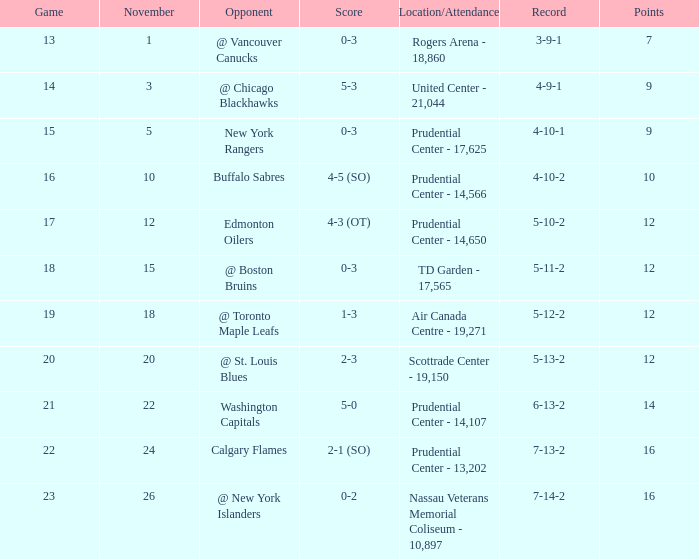What is the record for score 1-3? 5-12-2. I'm looking to parse the entire table for insights. Could you assist me with that? {'header': ['Game', 'November', 'Opponent', 'Score', 'Location/Attendance', 'Record', 'Points'], 'rows': [['13', '1', '@ Vancouver Canucks', '0-3', 'Rogers Arena - 18,860', '3-9-1', '7'], ['14', '3', '@ Chicago Blackhawks', '5-3', 'United Center - 21,044', '4-9-1', '9'], ['15', '5', 'New York Rangers', '0-3', 'Prudential Center - 17,625', '4-10-1', '9'], ['16', '10', 'Buffalo Sabres', '4-5 (SO)', 'Prudential Center - 14,566', '4-10-2', '10'], ['17', '12', 'Edmonton Oilers', '4-3 (OT)', 'Prudential Center - 14,650', '5-10-2', '12'], ['18', '15', '@ Boston Bruins', '0-3', 'TD Garden - 17,565', '5-11-2', '12'], ['19', '18', '@ Toronto Maple Leafs', '1-3', 'Air Canada Centre - 19,271', '5-12-2', '12'], ['20', '20', '@ St. Louis Blues', '2-3', 'Scottrade Center - 19,150', '5-13-2', '12'], ['21', '22', 'Washington Capitals', '5-0', 'Prudential Center - 14,107', '6-13-2', '14'], ['22', '24', 'Calgary Flames', '2-1 (SO)', 'Prudential Center - 13,202', '7-13-2', '16'], ['23', '26', '@ New York Islanders', '0-2', 'Nassau Veterans Memorial Coliseum - 10,897', '7-14-2', '16']]} 